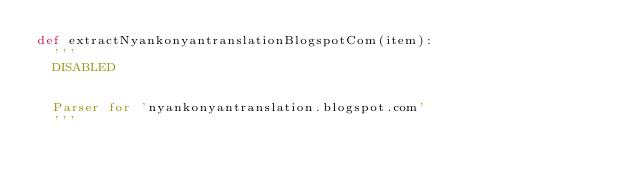Convert code to text. <code><loc_0><loc_0><loc_500><loc_500><_Python_>def extractNyankonyantranslationBlogspotCom(item):
	'''
	DISABLED 
	
	
	Parser for 'nyankonyantranslation.blogspot.com'
	'''
</code> 